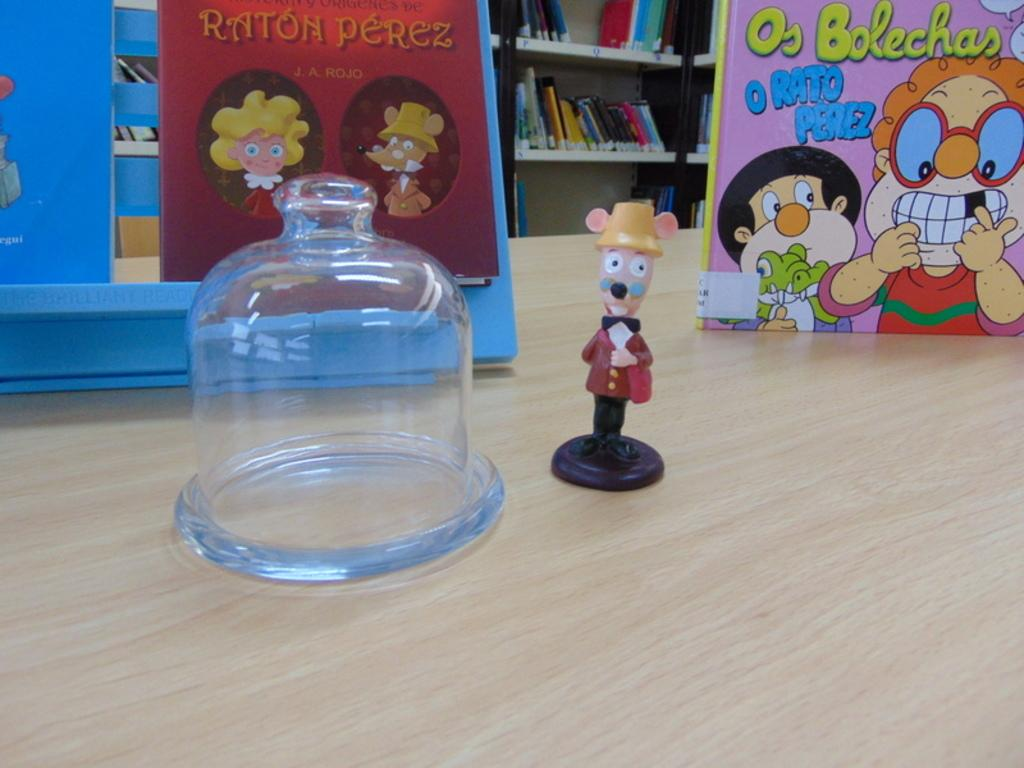<image>
Present a compact description of the photo's key features. A Raton Perez toy is on the table in front of some Raton Perez books. 